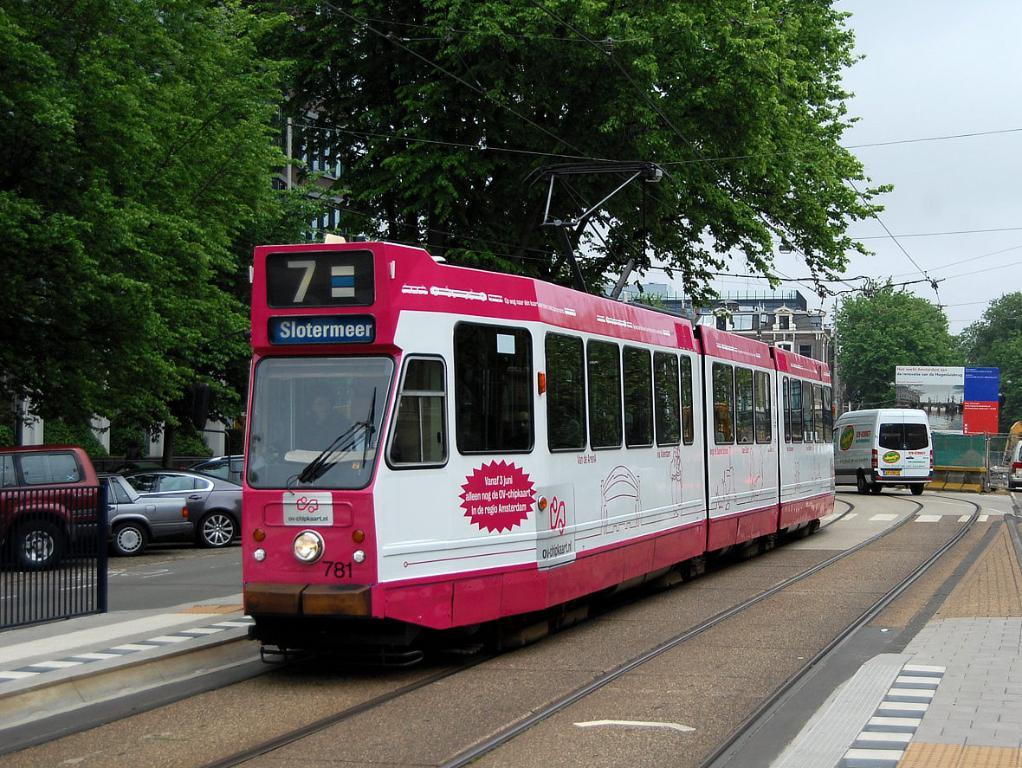<image>
Summarize the visual content of the image. A trolley train with a sign on the front stating "Slotermeer" 